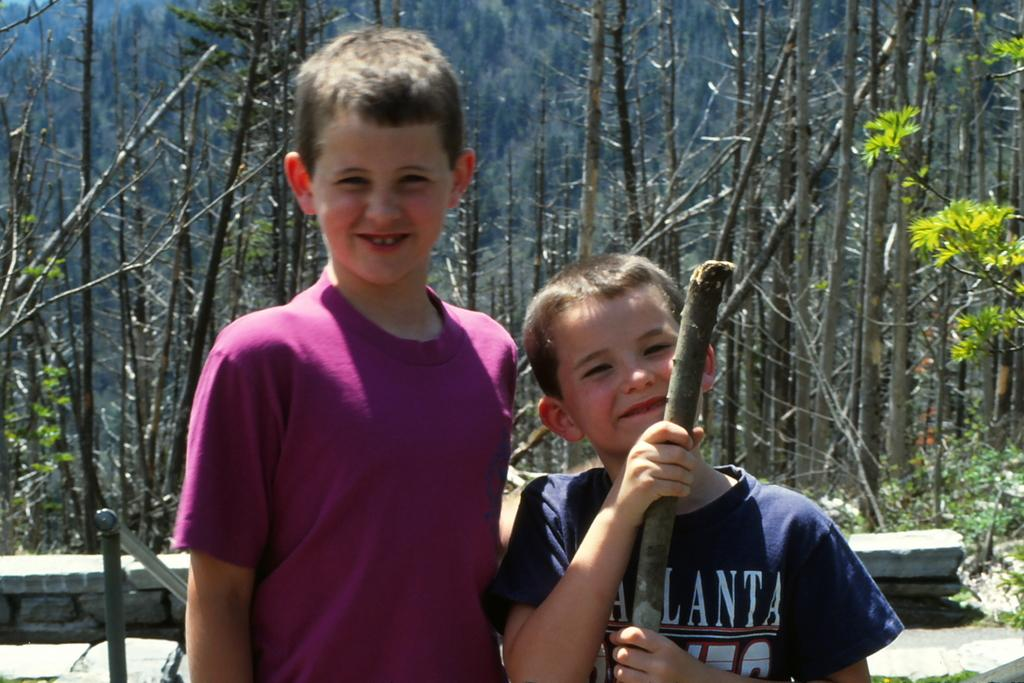How many kids are present in the image? There are two kids standing in the image. What can be seen in the background of the image? There are trees in the background of the image. What type of juice is being poured from the cast in the image? There is no cast or juice present in the image; it features two kids and trees in the background. 